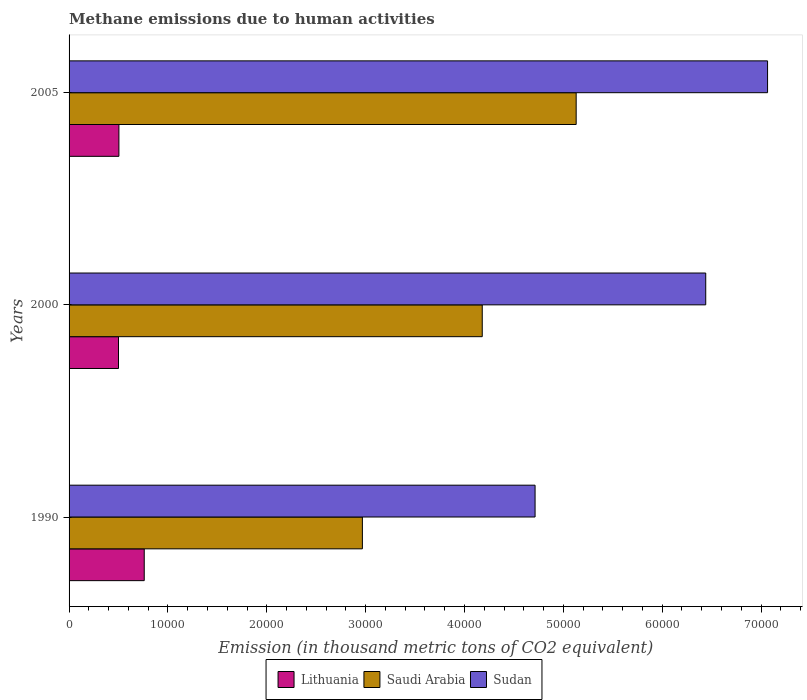Are the number of bars per tick equal to the number of legend labels?
Offer a terse response. Yes. Are the number of bars on each tick of the Y-axis equal?
Keep it short and to the point. Yes. How many bars are there on the 2nd tick from the top?
Provide a succinct answer. 3. How many bars are there on the 1st tick from the bottom?
Your answer should be very brief. 3. In how many cases, is the number of bars for a given year not equal to the number of legend labels?
Provide a short and direct response. 0. What is the amount of methane emitted in Saudi Arabia in 2000?
Offer a terse response. 4.18e+04. Across all years, what is the maximum amount of methane emitted in Lithuania?
Keep it short and to the point. 7603.6. Across all years, what is the minimum amount of methane emitted in Lithuania?
Your response must be concise. 5000.2. What is the total amount of methane emitted in Sudan in the graph?
Offer a very short reply. 1.82e+05. What is the difference between the amount of methane emitted in Saudi Arabia in 1990 and that in 2005?
Your answer should be very brief. -2.16e+04. What is the difference between the amount of methane emitted in Lithuania in 1990 and the amount of methane emitted in Saudi Arabia in 2000?
Offer a terse response. -3.42e+04. What is the average amount of methane emitted in Sudan per year?
Keep it short and to the point. 6.07e+04. In the year 2000, what is the difference between the amount of methane emitted in Lithuania and amount of methane emitted in Saudi Arabia?
Provide a succinct answer. -3.68e+04. In how many years, is the amount of methane emitted in Saudi Arabia greater than 68000 thousand metric tons?
Your response must be concise. 0. What is the ratio of the amount of methane emitted in Sudan in 1990 to that in 2000?
Your answer should be compact. 0.73. Is the difference between the amount of methane emitted in Lithuania in 2000 and 2005 greater than the difference between the amount of methane emitted in Saudi Arabia in 2000 and 2005?
Offer a terse response. Yes. What is the difference between the highest and the second highest amount of methane emitted in Lithuania?
Provide a short and direct response. 2561.4. What is the difference between the highest and the lowest amount of methane emitted in Lithuania?
Your answer should be very brief. 2603.4. Is the sum of the amount of methane emitted in Sudan in 2000 and 2005 greater than the maximum amount of methane emitted in Saudi Arabia across all years?
Provide a succinct answer. Yes. What does the 3rd bar from the top in 1990 represents?
Ensure brevity in your answer.  Lithuania. What does the 1st bar from the bottom in 1990 represents?
Your answer should be compact. Lithuania. Is it the case that in every year, the sum of the amount of methane emitted in Sudan and amount of methane emitted in Lithuania is greater than the amount of methane emitted in Saudi Arabia?
Your response must be concise. Yes. What is the difference between two consecutive major ticks on the X-axis?
Offer a terse response. 10000. Does the graph contain grids?
Offer a very short reply. No. Where does the legend appear in the graph?
Provide a succinct answer. Bottom center. What is the title of the graph?
Your response must be concise. Methane emissions due to human activities. What is the label or title of the X-axis?
Offer a terse response. Emission (in thousand metric tons of CO2 equivalent). What is the Emission (in thousand metric tons of CO2 equivalent) of Lithuania in 1990?
Provide a short and direct response. 7603.6. What is the Emission (in thousand metric tons of CO2 equivalent) of Saudi Arabia in 1990?
Offer a terse response. 2.97e+04. What is the Emission (in thousand metric tons of CO2 equivalent) in Sudan in 1990?
Your answer should be very brief. 4.71e+04. What is the Emission (in thousand metric tons of CO2 equivalent) of Lithuania in 2000?
Ensure brevity in your answer.  5000.2. What is the Emission (in thousand metric tons of CO2 equivalent) of Saudi Arabia in 2000?
Make the answer very short. 4.18e+04. What is the Emission (in thousand metric tons of CO2 equivalent) in Sudan in 2000?
Your answer should be compact. 6.44e+04. What is the Emission (in thousand metric tons of CO2 equivalent) of Lithuania in 2005?
Provide a short and direct response. 5042.2. What is the Emission (in thousand metric tons of CO2 equivalent) in Saudi Arabia in 2005?
Make the answer very short. 5.13e+04. What is the Emission (in thousand metric tons of CO2 equivalent) of Sudan in 2005?
Your response must be concise. 7.07e+04. Across all years, what is the maximum Emission (in thousand metric tons of CO2 equivalent) of Lithuania?
Provide a succinct answer. 7603.6. Across all years, what is the maximum Emission (in thousand metric tons of CO2 equivalent) in Saudi Arabia?
Give a very brief answer. 5.13e+04. Across all years, what is the maximum Emission (in thousand metric tons of CO2 equivalent) in Sudan?
Offer a terse response. 7.07e+04. Across all years, what is the minimum Emission (in thousand metric tons of CO2 equivalent) in Lithuania?
Offer a very short reply. 5000.2. Across all years, what is the minimum Emission (in thousand metric tons of CO2 equivalent) of Saudi Arabia?
Your response must be concise. 2.97e+04. Across all years, what is the minimum Emission (in thousand metric tons of CO2 equivalent) in Sudan?
Make the answer very short. 4.71e+04. What is the total Emission (in thousand metric tons of CO2 equivalent) of Lithuania in the graph?
Offer a terse response. 1.76e+04. What is the total Emission (in thousand metric tons of CO2 equivalent) in Saudi Arabia in the graph?
Keep it short and to the point. 1.23e+05. What is the total Emission (in thousand metric tons of CO2 equivalent) of Sudan in the graph?
Your response must be concise. 1.82e+05. What is the difference between the Emission (in thousand metric tons of CO2 equivalent) of Lithuania in 1990 and that in 2000?
Your answer should be compact. 2603.4. What is the difference between the Emission (in thousand metric tons of CO2 equivalent) of Saudi Arabia in 1990 and that in 2000?
Your answer should be very brief. -1.21e+04. What is the difference between the Emission (in thousand metric tons of CO2 equivalent) of Sudan in 1990 and that in 2000?
Give a very brief answer. -1.73e+04. What is the difference between the Emission (in thousand metric tons of CO2 equivalent) in Lithuania in 1990 and that in 2005?
Make the answer very short. 2561.4. What is the difference between the Emission (in thousand metric tons of CO2 equivalent) of Saudi Arabia in 1990 and that in 2005?
Provide a succinct answer. -2.16e+04. What is the difference between the Emission (in thousand metric tons of CO2 equivalent) in Sudan in 1990 and that in 2005?
Provide a short and direct response. -2.35e+04. What is the difference between the Emission (in thousand metric tons of CO2 equivalent) of Lithuania in 2000 and that in 2005?
Provide a short and direct response. -42. What is the difference between the Emission (in thousand metric tons of CO2 equivalent) of Saudi Arabia in 2000 and that in 2005?
Give a very brief answer. -9501.6. What is the difference between the Emission (in thousand metric tons of CO2 equivalent) in Sudan in 2000 and that in 2005?
Give a very brief answer. -6254.5. What is the difference between the Emission (in thousand metric tons of CO2 equivalent) of Lithuania in 1990 and the Emission (in thousand metric tons of CO2 equivalent) of Saudi Arabia in 2000?
Make the answer very short. -3.42e+04. What is the difference between the Emission (in thousand metric tons of CO2 equivalent) of Lithuania in 1990 and the Emission (in thousand metric tons of CO2 equivalent) of Sudan in 2000?
Your answer should be compact. -5.68e+04. What is the difference between the Emission (in thousand metric tons of CO2 equivalent) in Saudi Arabia in 1990 and the Emission (in thousand metric tons of CO2 equivalent) in Sudan in 2000?
Ensure brevity in your answer.  -3.47e+04. What is the difference between the Emission (in thousand metric tons of CO2 equivalent) of Lithuania in 1990 and the Emission (in thousand metric tons of CO2 equivalent) of Saudi Arabia in 2005?
Give a very brief answer. -4.37e+04. What is the difference between the Emission (in thousand metric tons of CO2 equivalent) in Lithuania in 1990 and the Emission (in thousand metric tons of CO2 equivalent) in Sudan in 2005?
Your response must be concise. -6.31e+04. What is the difference between the Emission (in thousand metric tons of CO2 equivalent) in Saudi Arabia in 1990 and the Emission (in thousand metric tons of CO2 equivalent) in Sudan in 2005?
Offer a terse response. -4.10e+04. What is the difference between the Emission (in thousand metric tons of CO2 equivalent) in Lithuania in 2000 and the Emission (in thousand metric tons of CO2 equivalent) in Saudi Arabia in 2005?
Your answer should be very brief. -4.63e+04. What is the difference between the Emission (in thousand metric tons of CO2 equivalent) of Lithuania in 2000 and the Emission (in thousand metric tons of CO2 equivalent) of Sudan in 2005?
Offer a very short reply. -6.57e+04. What is the difference between the Emission (in thousand metric tons of CO2 equivalent) in Saudi Arabia in 2000 and the Emission (in thousand metric tons of CO2 equivalent) in Sudan in 2005?
Ensure brevity in your answer.  -2.89e+04. What is the average Emission (in thousand metric tons of CO2 equivalent) in Lithuania per year?
Provide a succinct answer. 5882. What is the average Emission (in thousand metric tons of CO2 equivalent) of Saudi Arabia per year?
Ensure brevity in your answer.  4.09e+04. What is the average Emission (in thousand metric tons of CO2 equivalent) in Sudan per year?
Offer a very short reply. 6.07e+04. In the year 1990, what is the difference between the Emission (in thousand metric tons of CO2 equivalent) in Lithuania and Emission (in thousand metric tons of CO2 equivalent) in Saudi Arabia?
Make the answer very short. -2.21e+04. In the year 1990, what is the difference between the Emission (in thousand metric tons of CO2 equivalent) of Lithuania and Emission (in thousand metric tons of CO2 equivalent) of Sudan?
Offer a terse response. -3.95e+04. In the year 1990, what is the difference between the Emission (in thousand metric tons of CO2 equivalent) of Saudi Arabia and Emission (in thousand metric tons of CO2 equivalent) of Sudan?
Offer a very short reply. -1.75e+04. In the year 2000, what is the difference between the Emission (in thousand metric tons of CO2 equivalent) of Lithuania and Emission (in thousand metric tons of CO2 equivalent) of Saudi Arabia?
Provide a succinct answer. -3.68e+04. In the year 2000, what is the difference between the Emission (in thousand metric tons of CO2 equivalent) of Lithuania and Emission (in thousand metric tons of CO2 equivalent) of Sudan?
Provide a succinct answer. -5.94e+04. In the year 2000, what is the difference between the Emission (in thousand metric tons of CO2 equivalent) in Saudi Arabia and Emission (in thousand metric tons of CO2 equivalent) in Sudan?
Offer a very short reply. -2.26e+04. In the year 2005, what is the difference between the Emission (in thousand metric tons of CO2 equivalent) of Lithuania and Emission (in thousand metric tons of CO2 equivalent) of Saudi Arabia?
Give a very brief answer. -4.63e+04. In the year 2005, what is the difference between the Emission (in thousand metric tons of CO2 equivalent) of Lithuania and Emission (in thousand metric tons of CO2 equivalent) of Sudan?
Your answer should be compact. -6.56e+04. In the year 2005, what is the difference between the Emission (in thousand metric tons of CO2 equivalent) in Saudi Arabia and Emission (in thousand metric tons of CO2 equivalent) in Sudan?
Keep it short and to the point. -1.94e+04. What is the ratio of the Emission (in thousand metric tons of CO2 equivalent) of Lithuania in 1990 to that in 2000?
Give a very brief answer. 1.52. What is the ratio of the Emission (in thousand metric tons of CO2 equivalent) of Saudi Arabia in 1990 to that in 2000?
Provide a succinct answer. 0.71. What is the ratio of the Emission (in thousand metric tons of CO2 equivalent) in Sudan in 1990 to that in 2000?
Provide a succinct answer. 0.73. What is the ratio of the Emission (in thousand metric tons of CO2 equivalent) of Lithuania in 1990 to that in 2005?
Your answer should be compact. 1.51. What is the ratio of the Emission (in thousand metric tons of CO2 equivalent) of Saudi Arabia in 1990 to that in 2005?
Offer a very short reply. 0.58. What is the ratio of the Emission (in thousand metric tons of CO2 equivalent) of Sudan in 1990 to that in 2005?
Offer a terse response. 0.67. What is the ratio of the Emission (in thousand metric tons of CO2 equivalent) in Saudi Arabia in 2000 to that in 2005?
Your response must be concise. 0.81. What is the ratio of the Emission (in thousand metric tons of CO2 equivalent) in Sudan in 2000 to that in 2005?
Provide a succinct answer. 0.91. What is the difference between the highest and the second highest Emission (in thousand metric tons of CO2 equivalent) in Lithuania?
Ensure brevity in your answer.  2561.4. What is the difference between the highest and the second highest Emission (in thousand metric tons of CO2 equivalent) in Saudi Arabia?
Your answer should be compact. 9501.6. What is the difference between the highest and the second highest Emission (in thousand metric tons of CO2 equivalent) of Sudan?
Your answer should be compact. 6254.5. What is the difference between the highest and the lowest Emission (in thousand metric tons of CO2 equivalent) in Lithuania?
Keep it short and to the point. 2603.4. What is the difference between the highest and the lowest Emission (in thousand metric tons of CO2 equivalent) of Saudi Arabia?
Ensure brevity in your answer.  2.16e+04. What is the difference between the highest and the lowest Emission (in thousand metric tons of CO2 equivalent) of Sudan?
Offer a terse response. 2.35e+04. 